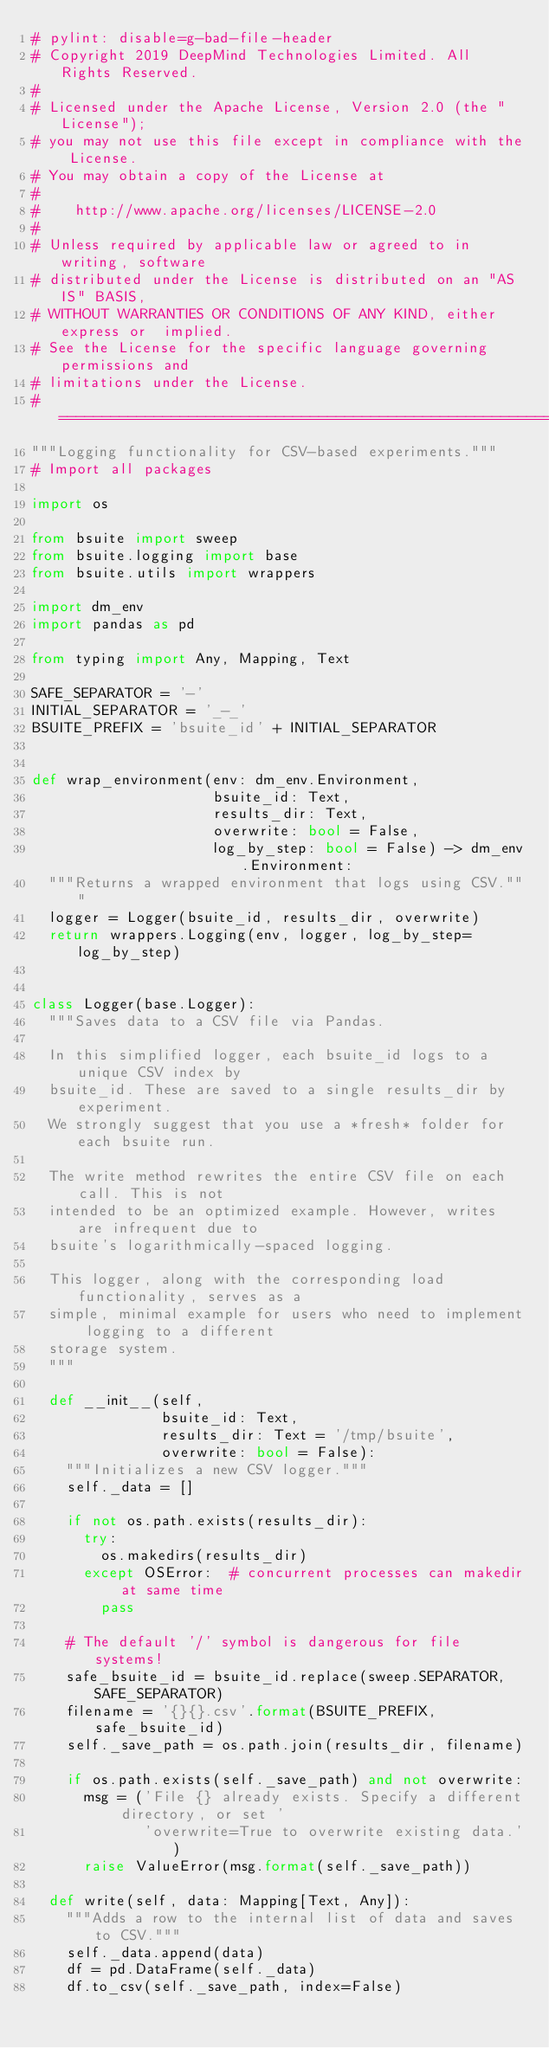Convert code to text. <code><loc_0><loc_0><loc_500><loc_500><_Python_># pylint: disable=g-bad-file-header
# Copyright 2019 DeepMind Technologies Limited. All Rights Reserved.
#
# Licensed under the Apache License, Version 2.0 (the "License");
# you may not use this file except in compliance with the License.
# You may obtain a copy of the License at
#
#    http://www.apache.org/licenses/LICENSE-2.0
#
# Unless required by applicable law or agreed to in writing, software
# distributed under the License is distributed on an "AS IS" BASIS,
# WITHOUT WARRANTIES OR CONDITIONS OF ANY KIND, either express or  implied.
# See the License for the specific language governing permissions and
# limitations under the License.
# ============================================================================
"""Logging functionality for CSV-based experiments."""
# Import all packages

import os

from bsuite import sweep
from bsuite.logging import base
from bsuite.utils import wrappers

import dm_env
import pandas as pd

from typing import Any, Mapping, Text

SAFE_SEPARATOR = '-'
INITIAL_SEPARATOR = '_-_'
BSUITE_PREFIX = 'bsuite_id' + INITIAL_SEPARATOR


def wrap_environment(env: dm_env.Environment,
                     bsuite_id: Text,
                     results_dir: Text,
                     overwrite: bool = False,
                     log_by_step: bool = False) -> dm_env.Environment:
  """Returns a wrapped environment that logs using CSV."""
  logger = Logger(bsuite_id, results_dir, overwrite)
  return wrappers.Logging(env, logger, log_by_step=log_by_step)


class Logger(base.Logger):
  """Saves data to a CSV file via Pandas.

  In this simplified logger, each bsuite_id logs to a unique CSV index by
  bsuite_id. These are saved to a single results_dir by experiment.
  We strongly suggest that you use a *fresh* folder for each bsuite run.

  The write method rewrites the entire CSV file on each call. This is not
  intended to be an optimized example. However, writes are infrequent due to
  bsuite's logarithmically-spaced logging.

  This logger, along with the corresponding load functionality, serves as a
  simple, minimal example for users who need to implement logging to a different
  storage system.
  """

  def __init__(self,
               bsuite_id: Text,
               results_dir: Text = '/tmp/bsuite',
               overwrite: bool = False):
    """Initializes a new CSV logger."""
    self._data = []

    if not os.path.exists(results_dir):
      try:
        os.makedirs(results_dir)
      except OSError:  # concurrent processes can makedir at same time
        pass

    # The default '/' symbol is dangerous for file systems!
    safe_bsuite_id = bsuite_id.replace(sweep.SEPARATOR, SAFE_SEPARATOR)
    filename = '{}{}.csv'.format(BSUITE_PREFIX, safe_bsuite_id)
    self._save_path = os.path.join(results_dir, filename)

    if os.path.exists(self._save_path) and not overwrite:
      msg = ('File {} already exists. Specify a different directory, or set '
             'overwrite=True to overwrite existing data.')
      raise ValueError(msg.format(self._save_path))

  def write(self, data: Mapping[Text, Any]):
    """Adds a row to the internal list of data and saves to CSV."""
    self._data.append(data)
    df = pd.DataFrame(self._data)
    df.to_csv(self._save_path, index=False)
</code> 